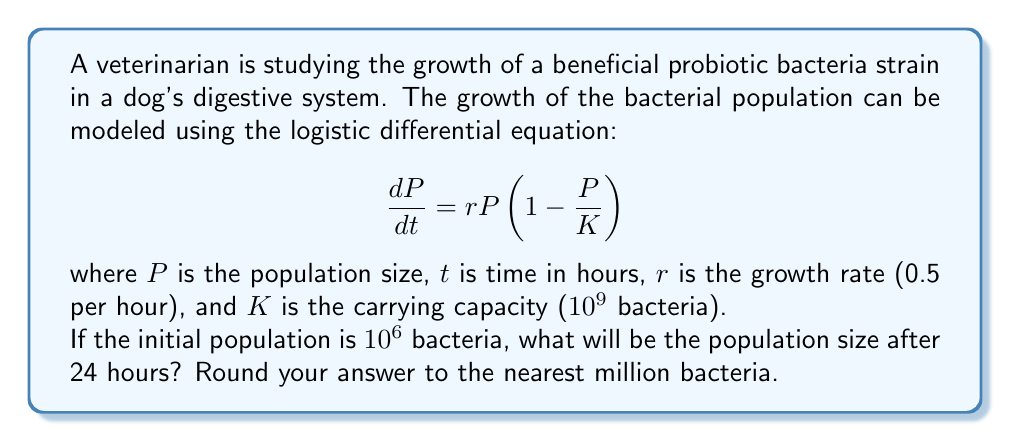Show me your answer to this math problem. To solve this problem, we'll follow these steps:

1) The logistic differential equation has the general solution:

   $$P(t) = \frac{K}{1 + (\frac{K}{P_0} - 1)e^{-rt}}$$

   where $P_0$ is the initial population.

2) We're given:
   $K = 10^9$
   $r = 0.5$
   $P_0 = 10^6$
   $t = 24$

3) Let's substitute these values into the equation:

   $$P(24) = \frac{10^9}{1 + (\frac{10^9}{10^6} - 1)e^{-0.5(24)}}$$

4) Simplify:
   $$P(24) = \frac{10^9}{1 + (999)e^{-12}}$$

5) Calculate $e^{-12}$:
   $e^{-12} \approx 6.14 \times 10^{-6}$

6) Substitute this value:
   $$P(24) = \frac{10^9}{1 + (999)(6.14 \times 10^{-6})}$$

7) Simplify:
   $$P(24) = \frac{10^9}{1 + 0.00613} = \frac{10^9}{1.00613}$$

8) Calculate:
   $$P(24) \approx 993,930,690$$

9) Rounding to the nearest million:
   $$P(24) \approx 994,000,000 = 994 \times 10^6$$
Answer: 994 million bacteria 